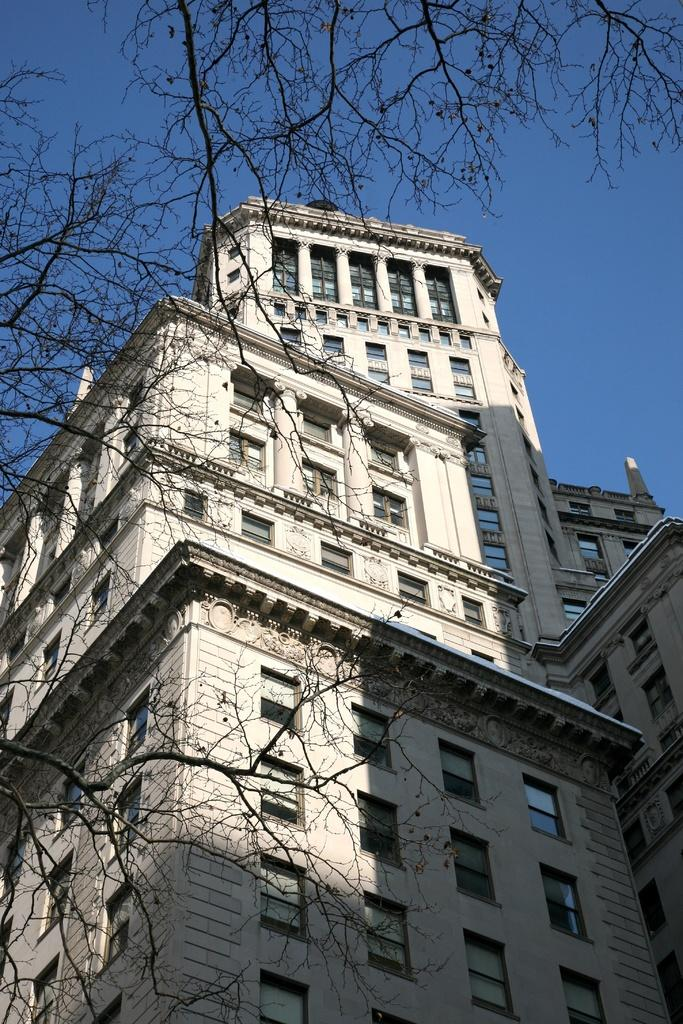What type of structure is in the image? There is a multi-story building in the image. What can be seen on the left side of the image? There is a dried tree on the left side of the image. What is visible at the top of the image? The sky is visible at the top of the image. What type of headwear is the stove wearing in the image? There is no stove present in the image, and therefore no headwear can be observed. 